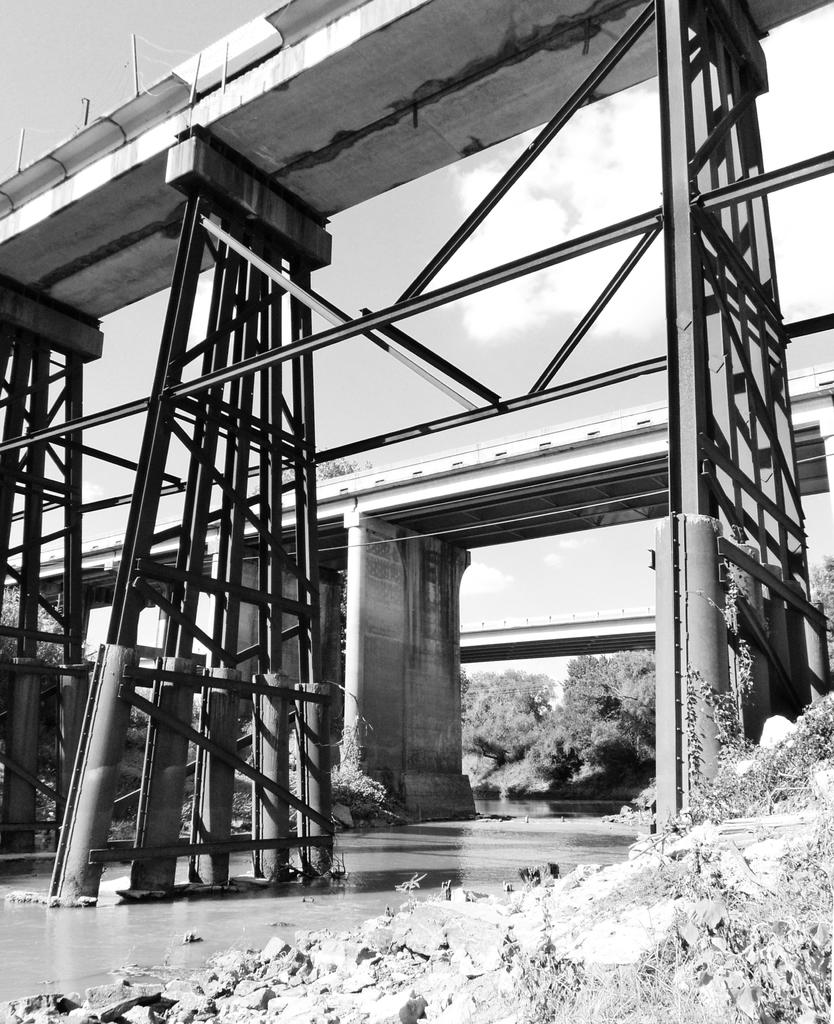What is the color scheme of the image? The image is black and white. How many bridges can be seen in the image? There are three bridges in the image. What type of vegetation is present in the image? There are trees in the image. What is the condition of the sky in the image? The sky is cloudy in the image. What is visible at the bottom of the image? There is water visible at the bottom of the image. Is the area around the bridges known for its quiet atmosphere in the image? The image does not provide information about the noise level or atmosphere around the bridges. What type of power source is used by the bridges in the image? The image does not provide information about the power source or construction of the bridges. 